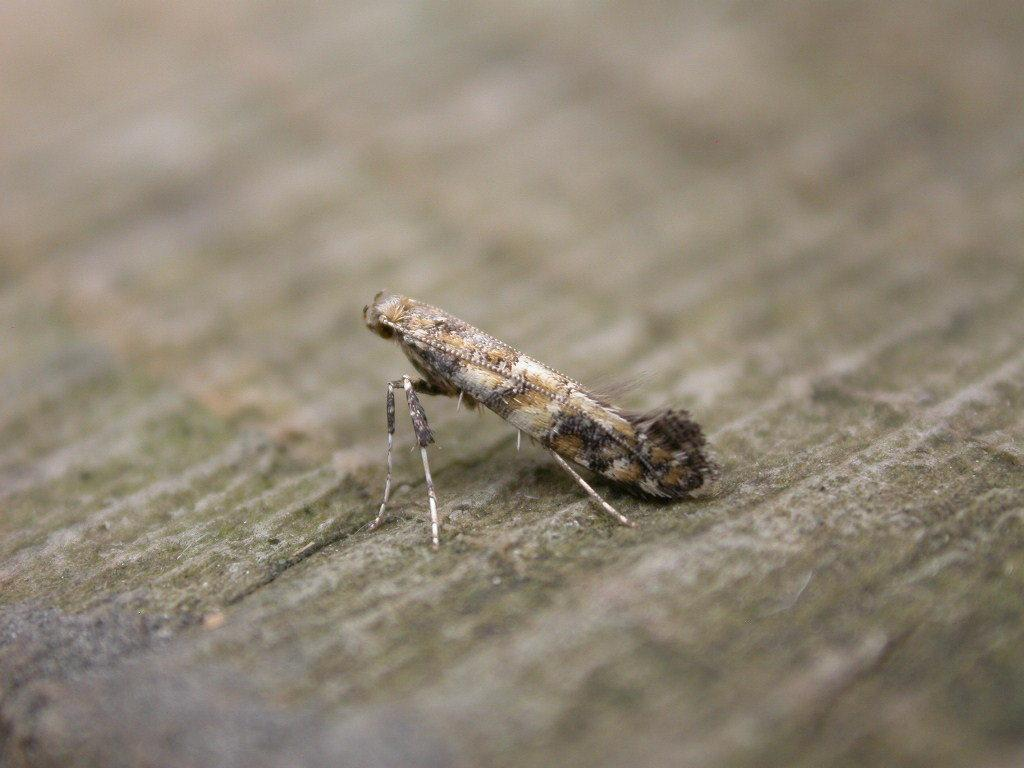What is the main subject of the image? There is a leaf hopper in the image. Can you describe the background of the image? The background of the image is blurry. Where is the faucet located in the image? There is no faucet present in the image. What type of marble can be seen in the image? There is no marble present in the image. 